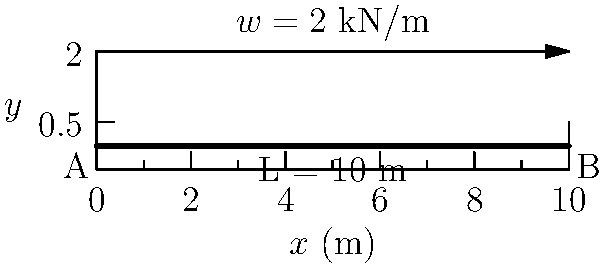As a sales representative familiar with mobile device specifications, consider a simply supported beam representing a shelf for displaying phones. The beam is 10 meters long and supports a uniformly distributed load of 2 kN/m, similar to the weight distribution of multiple devices. Determine the maximum shear force and bending moment in the beam. Let's approach this step-by-step:

1) For a simply supported beam with a uniformly distributed load:
   - Maximum shear force occurs at the supports
   - Maximum bending moment occurs at the center of the beam

2) Calculate the total load:
   $w = 2$ kN/m
   $L = 10$ m
   Total load = $w \times L = 2 \times 10 = 20$ kN

3) Reaction forces at supports:
   Due to symmetry, each support carries half the total load
   $R_A = R_B = \frac{20}{2} = 10$ kN

4) Maximum Shear Force:
   The maximum shear force is equal to the reaction force at either support
   $V_{max} = 10$ kN

5) Maximum Bending Moment:
   For a uniformly distributed load, the maximum bending moment occurs at the center and is given by:
   $M_{max} = \frac{wL^2}{8}$
   $M_{max} = \frac{2 \times 10^2}{8} = \frac{200}{8} = 25$ kN⋅m

Therefore, the maximum shear force is 10 kN and the maximum bending moment is 25 kN⋅m.
Answer: $V_{max} = 10$ kN, $M_{max} = 25$ kN⋅m 